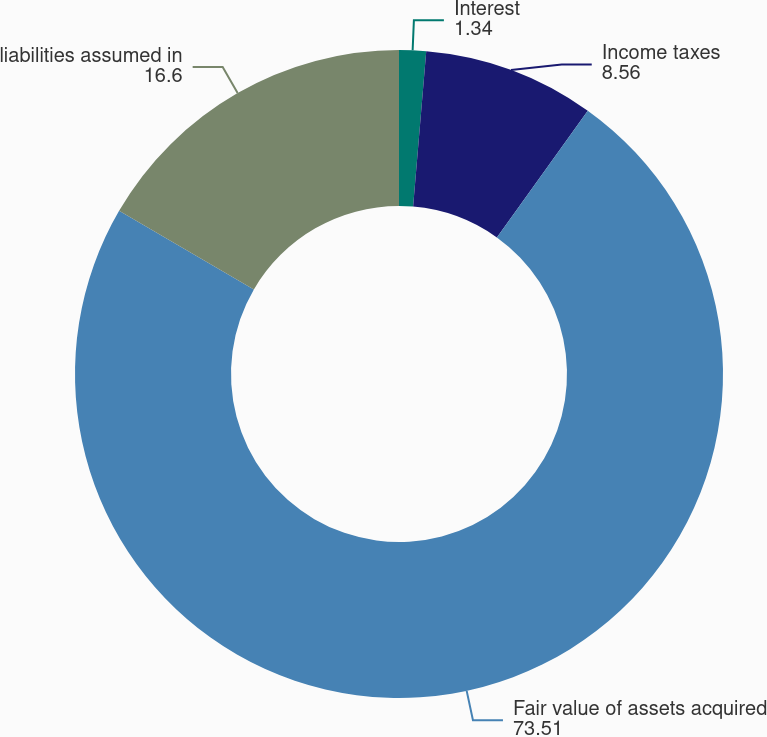Convert chart to OTSL. <chart><loc_0><loc_0><loc_500><loc_500><pie_chart><fcel>Interest<fcel>Income taxes<fcel>Fair value of assets acquired<fcel>liabilities assumed in<nl><fcel>1.34%<fcel>8.56%<fcel>73.51%<fcel>16.6%<nl></chart> 